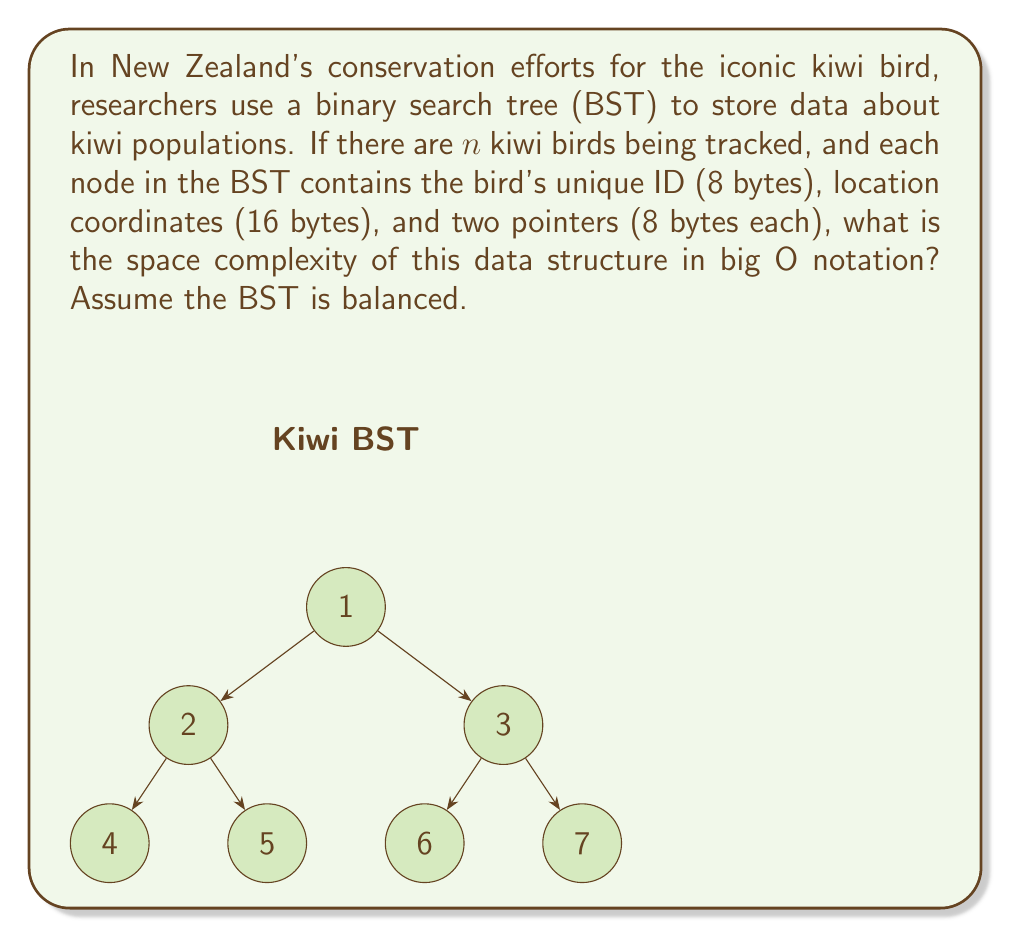Could you help me with this problem? Let's break this down step-by-step:

1) First, let's calculate the space required for each node:
   - Unique ID: 8 bytes
   - Location coordinates: 16 bytes
   - Two pointers: 2 * 8 = 16 bytes
   Total per node: 8 + 16 + 16 = 40 bytes

2) In a balanced BST, the height of the tree is approximately $\log_2(n)$, where $n$ is the number of nodes.

3) The space complexity of a BST is determined by the number of nodes. Each node takes a constant amount of space (40 bytes in this case), and there are $n$ nodes in total.

4) Therefore, the total space used is:
   $$ \text{Total Space} = 40 * n \text{ bytes} $$

5) In big O notation, we ignore constant factors. So, 40 * n simplifies to just n.

6) Thus, the space complexity of this BST is $O(n)$.

Note: The balanced nature of the BST affects its time complexity for operations like search and insert (which would be $O(\log n)$), but it doesn't change the space complexity. Whether balanced or not, we still need to store all $n$ nodes.
Answer: $O(n)$ 